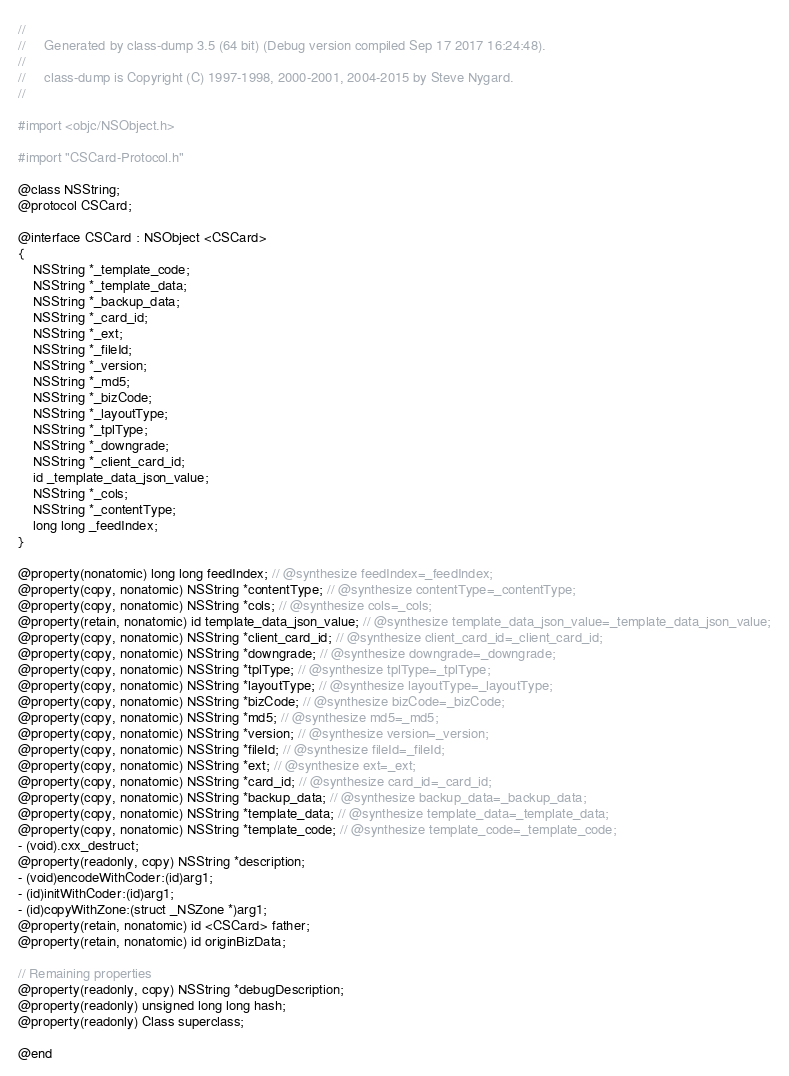<code> <loc_0><loc_0><loc_500><loc_500><_C_>//
//     Generated by class-dump 3.5 (64 bit) (Debug version compiled Sep 17 2017 16:24:48).
//
//     class-dump is Copyright (C) 1997-1998, 2000-2001, 2004-2015 by Steve Nygard.
//

#import <objc/NSObject.h>

#import "CSCard-Protocol.h"

@class NSString;
@protocol CSCard;

@interface CSCard : NSObject <CSCard>
{
    NSString *_template_code;
    NSString *_template_data;
    NSString *_backup_data;
    NSString *_card_id;
    NSString *_ext;
    NSString *_fileId;
    NSString *_version;
    NSString *_md5;
    NSString *_bizCode;
    NSString *_layoutType;
    NSString *_tplType;
    NSString *_downgrade;
    NSString *_client_card_id;
    id _template_data_json_value;
    NSString *_cols;
    NSString *_contentType;
    long long _feedIndex;
}

@property(nonatomic) long long feedIndex; // @synthesize feedIndex=_feedIndex;
@property(copy, nonatomic) NSString *contentType; // @synthesize contentType=_contentType;
@property(copy, nonatomic) NSString *cols; // @synthesize cols=_cols;
@property(retain, nonatomic) id template_data_json_value; // @synthesize template_data_json_value=_template_data_json_value;
@property(copy, nonatomic) NSString *client_card_id; // @synthesize client_card_id=_client_card_id;
@property(copy, nonatomic) NSString *downgrade; // @synthesize downgrade=_downgrade;
@property(copy, nonatomic) NSString *tplType; // @synthesize tplType=_tplType;
@property(copy, nonatomic) NSString *layoutType; // @synthesize layoutType=_layoutType;
@property(copy, nonatomic) NSString *bizCode; // @synthesize bizCode=_bizCode;
@property(copy, nonatomic) NSString *md5; // @synthesize md5=_md5;
@property(copy, nonatomic) NSString *version; // @synthesize version=_version;
@property(copy, nonatomic) NSString *fileId; // @synthesize fileId=_fileId;
@property(copy, nonatomic) NSString *ext; // @synthesize ext=_ext;
@property(copy, nonatomic) NSString *card_id; // @synthesize card_id=_card_id;
@property(copy, nonatomic) NSString *backup_data; // @synthesize backup_data=_backup_data;
@property(copy, nonatomic) NSString *template_data; // @synthesize template_data=_template_data;
@property(copy, nonatomic) NSString *template_code; // @synthesize template_code=_template_code;
- (void).cxx_destruct;
@property(readonly, copy) NSString *description;
- (void)encodeWithCoder:(id)arg1;
- (id)initWithCoder:(id)arg1;
- (id)copyWithZone:(struct _NSZone *)arg1;
@property(retain, nonatomic) id <CSCard> father;
@property(retain, nonatomic) id originBizData;

// Remaining properties
@property(readonly, copy) NSString *debugDescription;
@property(readonly) unsigned long long hash;
@property(readonly) Class superclass;

@end

</code> 